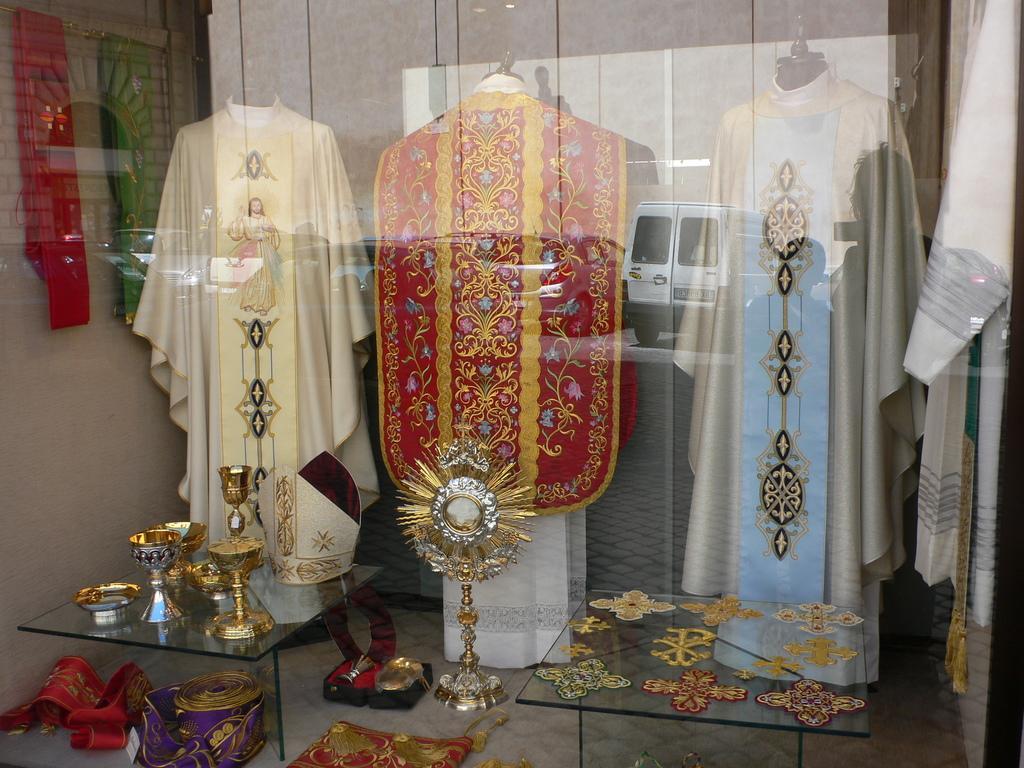Can you describe this image briefly? In this picture we can see a few clothes displayed in the shop. There are a few objects on a glass table. We can see some colorful objects on the floor. There are a few embroidery clothes on a glass table. We can see a white garment on the right side. 